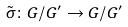Convert formula to latex. <formula><loc_0><loc_0><loc_500><loc_500>\tilde { \sigma } \colon G / G ^ { \prime } \rightarrow G / G ^ { \prime }</formula> 